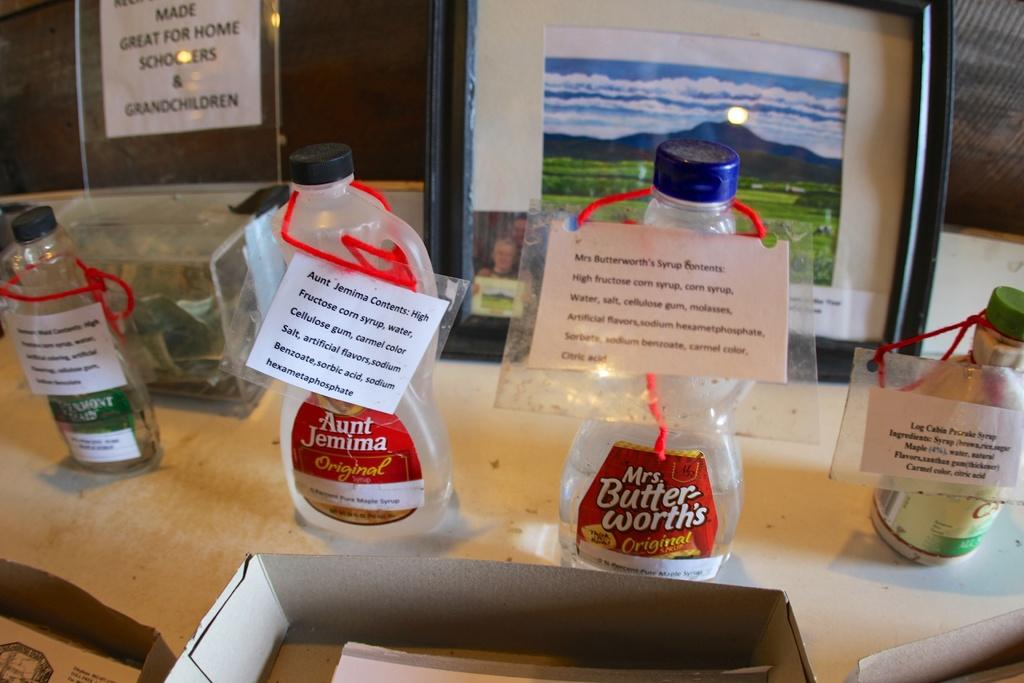<image>
Provide a brief description of the given image. Several empty bottles, including Aunt Jemima and Mrs. Butterworth's, are on a counter with signs attached to them. 